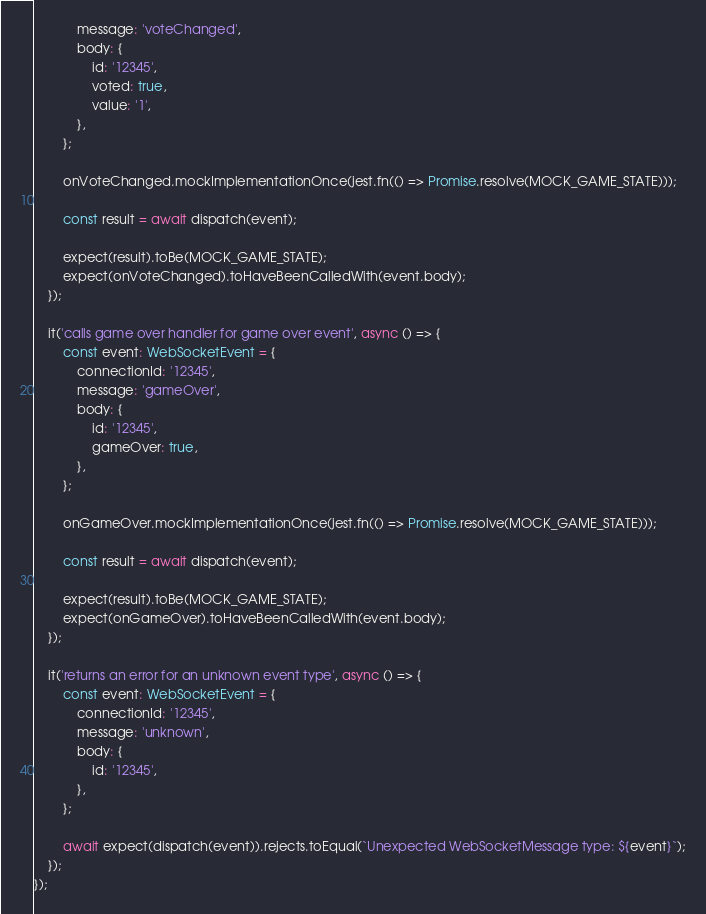Convert code to text. <code><loc_0><loc_0><loc_500><loc_500><_TypeScript_>            message: 'voteChanged',
            body: {
                id: '12345',
                voted: true,
                value: '1',
            },
        };

        onVoteChanged.mockImplementationOnce(jest.fn(() => Promise.resolve(MOCK_GAME_STATE)));

        const result = await dispatch(event);

        expect(result).toBe(MOCK_GAME_STATE);
        expect(onVoteChanged).toHaveBeenCalledWith(event.body);
    });

    it('calls game over handler for game over event', async () => {
        const event: WebSocketEvent = {
            connectionId: '12345',
            message: 'gameOver',
            body: {
                id: '12345',
                gameOver: true,
            },
        };

        onGameOver.mockImplementationOnce(jest.fn(() => Promise.resolve(MOCK_GAME_STATE)));

        const result = await dispatch(event);

        expect(result).toBe(MOCK_GAME_STATE);
        expect(onGameOver).toHaveBeenCalledWith(event.body);
    });

    it('returns an error for an unknown event type', async () => {
        const event: WebSocketEvent = {
            connectionId: '12345',
            message: 'unknown',
            body: {
                id: '12345',
            },
        };

        await expect(dispatch(event)).rejects.toEqual(`Unexpected WebSocketMessage type: ${event}`);
    });
});</code> 